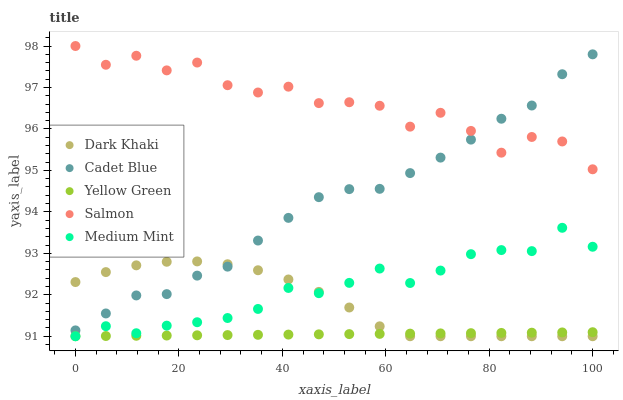Does Yellow Green have the minimum area under the curve?
Answer yes or no. Yes. Does Salmon have the maximum area under the curve?
Answer yes or no. Yes. Does Medium Mint have the minimum area under the curve?
Answer yes or no. No. Does Medium Mint have the maximum area under the curve?
Answer yes or no. No. Is Yellow Green the smoothest?
Answer yes or no. Yes. Is Salmon the roughest?
Answer yes or no. Yes. Is Medium Mint the smoothest?
Answer yes or no. No. Is Medium Mint the roughest?
Answer yes or no. No. Does Dark Khaki have the lowest value?
Answer yes or no. Yes. Does Cadet Blue have the lowest value?
Answer yes or no. No. Does Salmon have the highest value?
Answer yes or no. Yes. Does Medium Mint have the highest value?
Answer yes or no. No. Is Yellow Green less than Salmon?
Answer yes or no. Yes. Is Cadet Blue greater than Yellow Green?
Answer yes or no. Yes. Does Medium Mint intersect Yellow Green?
Answer yes or no. Yes. Is Medium Mint less than Yellow Green?
Answer yes or no. No. Is Medium Mint greater than Yellow Green?
Answer yes or no. No. Does Yellow Green intersect Salmon?
Answer yes or no. No. 